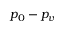Convert formula to latex. <formula><loc_0><loc_0><loc_500><loc_500>p _ { 0 } - p _ { v }</formula> 